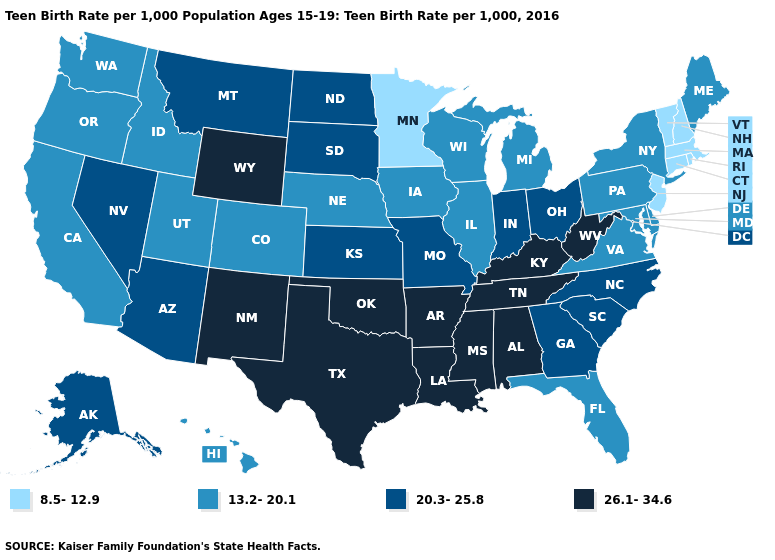What is the lowest value in the USA?
Write a very short answer. 8.5-12.9. What is the value of New Mexico?
Give a very brief answer. 26.1-34.6. How many symbols are there in the legend?
Be succinct. 4. What is the value of Virginia?
Quick response, please. 13.2-20.1. What is the value of Hawaii?
Write a very short answer. 13.2-20.1. Name the states that have a value in the range 20.3-25.8?
Quick response, please. Alaska, Arizona, Georgia, Indiana, Kansas, Missouri, Montana, Nevada, North Carolina, North Dakota, Ohio, South Carolina, South Dakota. Name the states that have a value in the range 20.3-25.8?
Concise answer only. Alaska, Arizona, Georgia, Indiana, Kansas, Missouri, Montana, Nevada, North Carolina, North Dakota, Ohio, South Carolina, South Dakota. Is the legend a continuous bar?
Give a very brief answer. No. What is the value of Nebraska?
Give a very brief answer. 13.2-20.1. Name the states that have a value in the range 26.1-34.6?
Concise answer only. Alabama, Arkansas, Kentucky, Louisiana, Mississippi, New Mexico, Oklahoma, Tennessee, Texas, West Virginia, Wyoming. What is the lowest value in the MidWest?
Keep it brief. 8.5-12.9. Name the states that have a value in the range 13.2-20.1?
Answer briefly. California, Colorado, Delaware, Florida, Hawaii, Idaho, Illinois, Iowa, Maine, Maryland, Michigan, Nebraska, New York, Oregon, Pennsylvania, Utah, Virginia, Washington, Wisconsin. What is the value of Michigan?
Keep it brief. 13.2-20.1. What is the lowest value in states that border Georgia?
Short answer required. 13.2-20.1. Does the first symbol in the legend represent the smallest category?
Short answer required. Yes. 